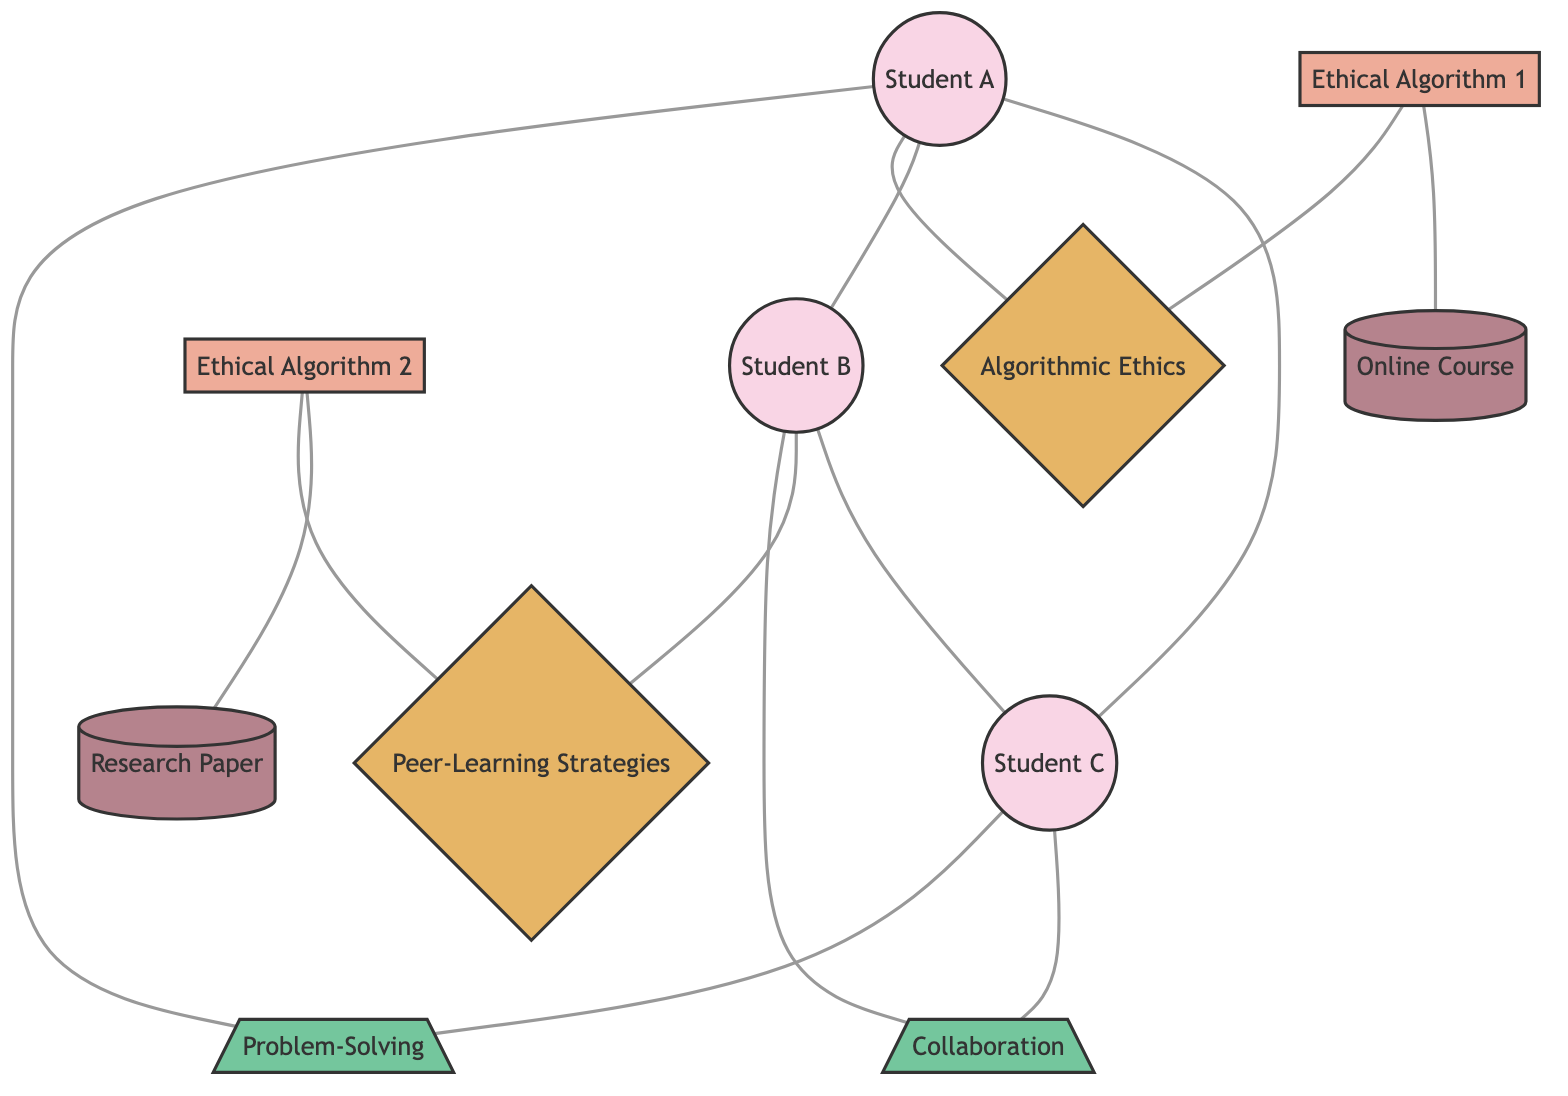What is the total number of nodes in the diagram? The diagram lists specific nodes representing students, algorithms, concepts, skills, and resources. Counting each of these yields 11 nodes in total.
Answer: 11 Which student is connected to the "Problem-Solving" skill? Examining the edges connected to the "Problem-Solving" skill reveals that both "Student A" and "Student C" are directly connected to it.
Answer: Student A, Student C How many skills are represented in the diagram? There are two skills listed in the nodes: "Problem-Solving" and "Collaboration." Therefore, the count of skills is 2.
Answer: 2 Which algorithm is associated with "Peer-Learning Strategies"? The edges indicate that "Ethical Algorithm 2" is connected to "Peer-Learning Strategies," making it the correct algorithm associated with this concept.
Answer: Ethical Algorithm 2 Which resource is connected to "Ethical Algorithm 1"? From the edges, we can see that "Ethical Algorithm 1" connects to "Online Course," indicating the direct relationship between them.
Answer: Online Course What type of relationship do Student A and Student B have? The edges demonstrate a direct connection between "Student A" and "Student B," indicating that they are peers in the learning environment.
Answer: Peer How many concepts are represented in the diagram? The diagram identifies two concepts: "Algorithmic Ethics" and "Peer-Learning Strategies." Thus, the number of concepts is 2.
Answer: 2 Which student is connected to both skills present in the diagram? Analyzing the edges shows that "Student C" is connected to both "Problem-Solving" and "Collaboration," making this student the only one with such a connection.
Answer: Student C Which resource is linked to "Ethical Algorithm 2"? The direct connection depicted in the edges indicates that "Ethical Algorithm 2" is linked to "Research Paper."
Answer: Research Paper 